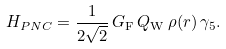Convert formula to latex. <formula><loc_0><loc_0><loc_500><loc_500>H _ { P N C } = \frac { 1 } { 2 \sqrt { 2 } } \, G _ { \mathrm F } \, Q _ { \mathrm W } \, \rho ( r ) \, \gamma _ { 5 } .</formula> 